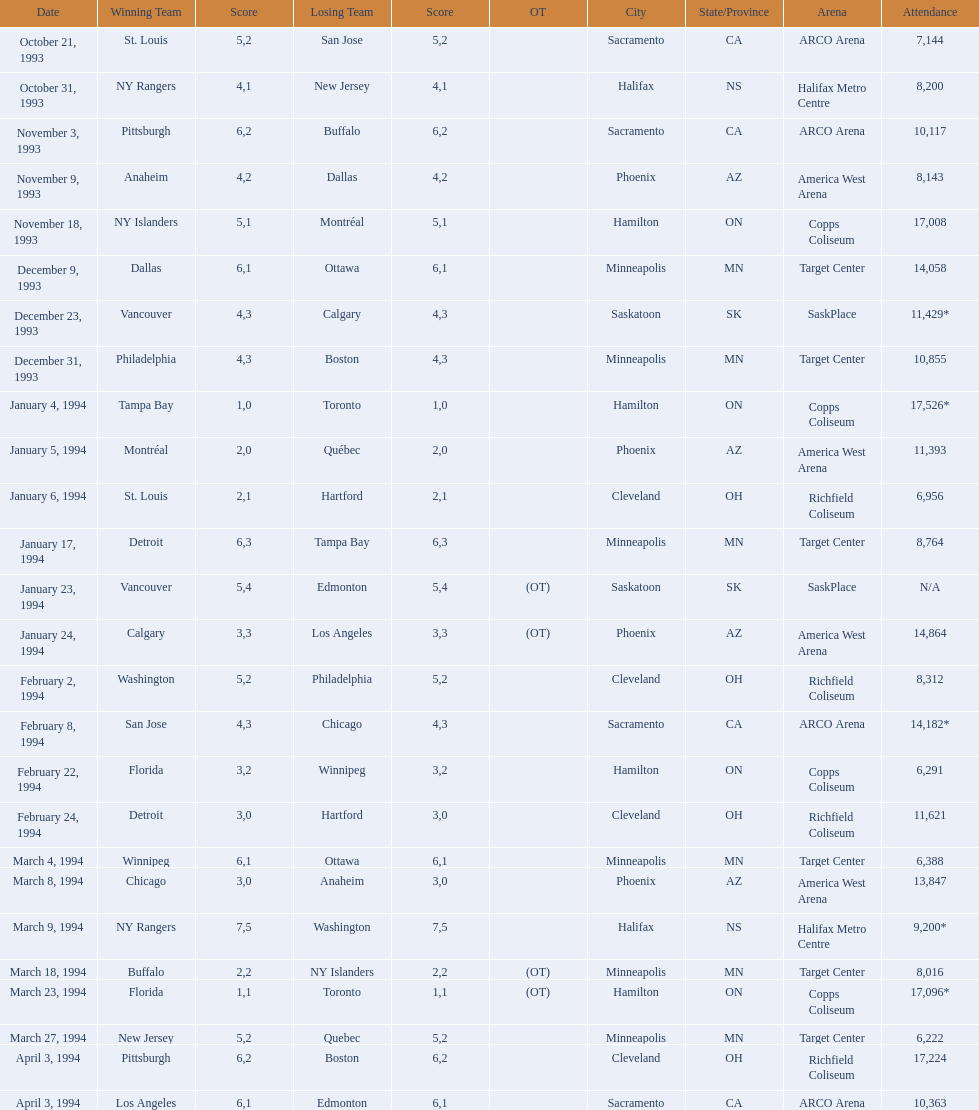On which date did the game have the highest attendance? January 4, 1994. 